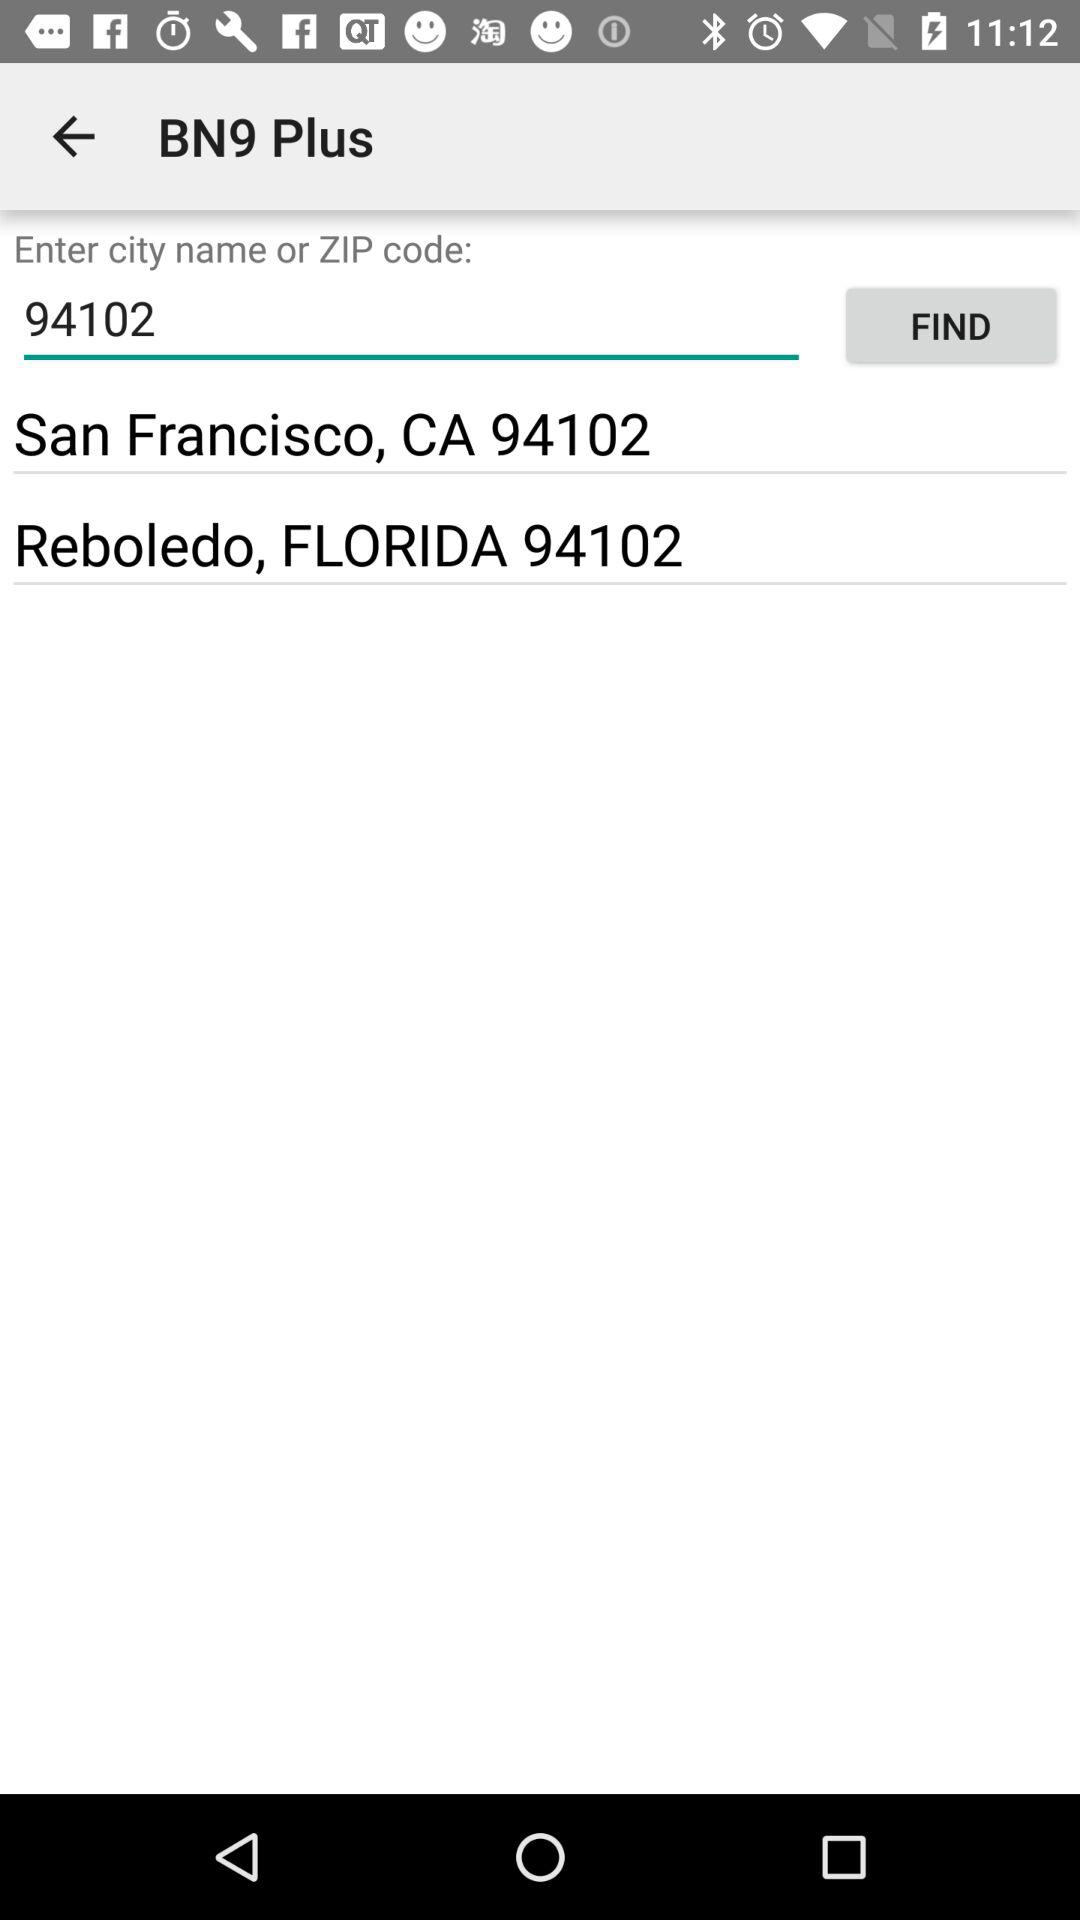What is the zip code? The zip code is 94102. 